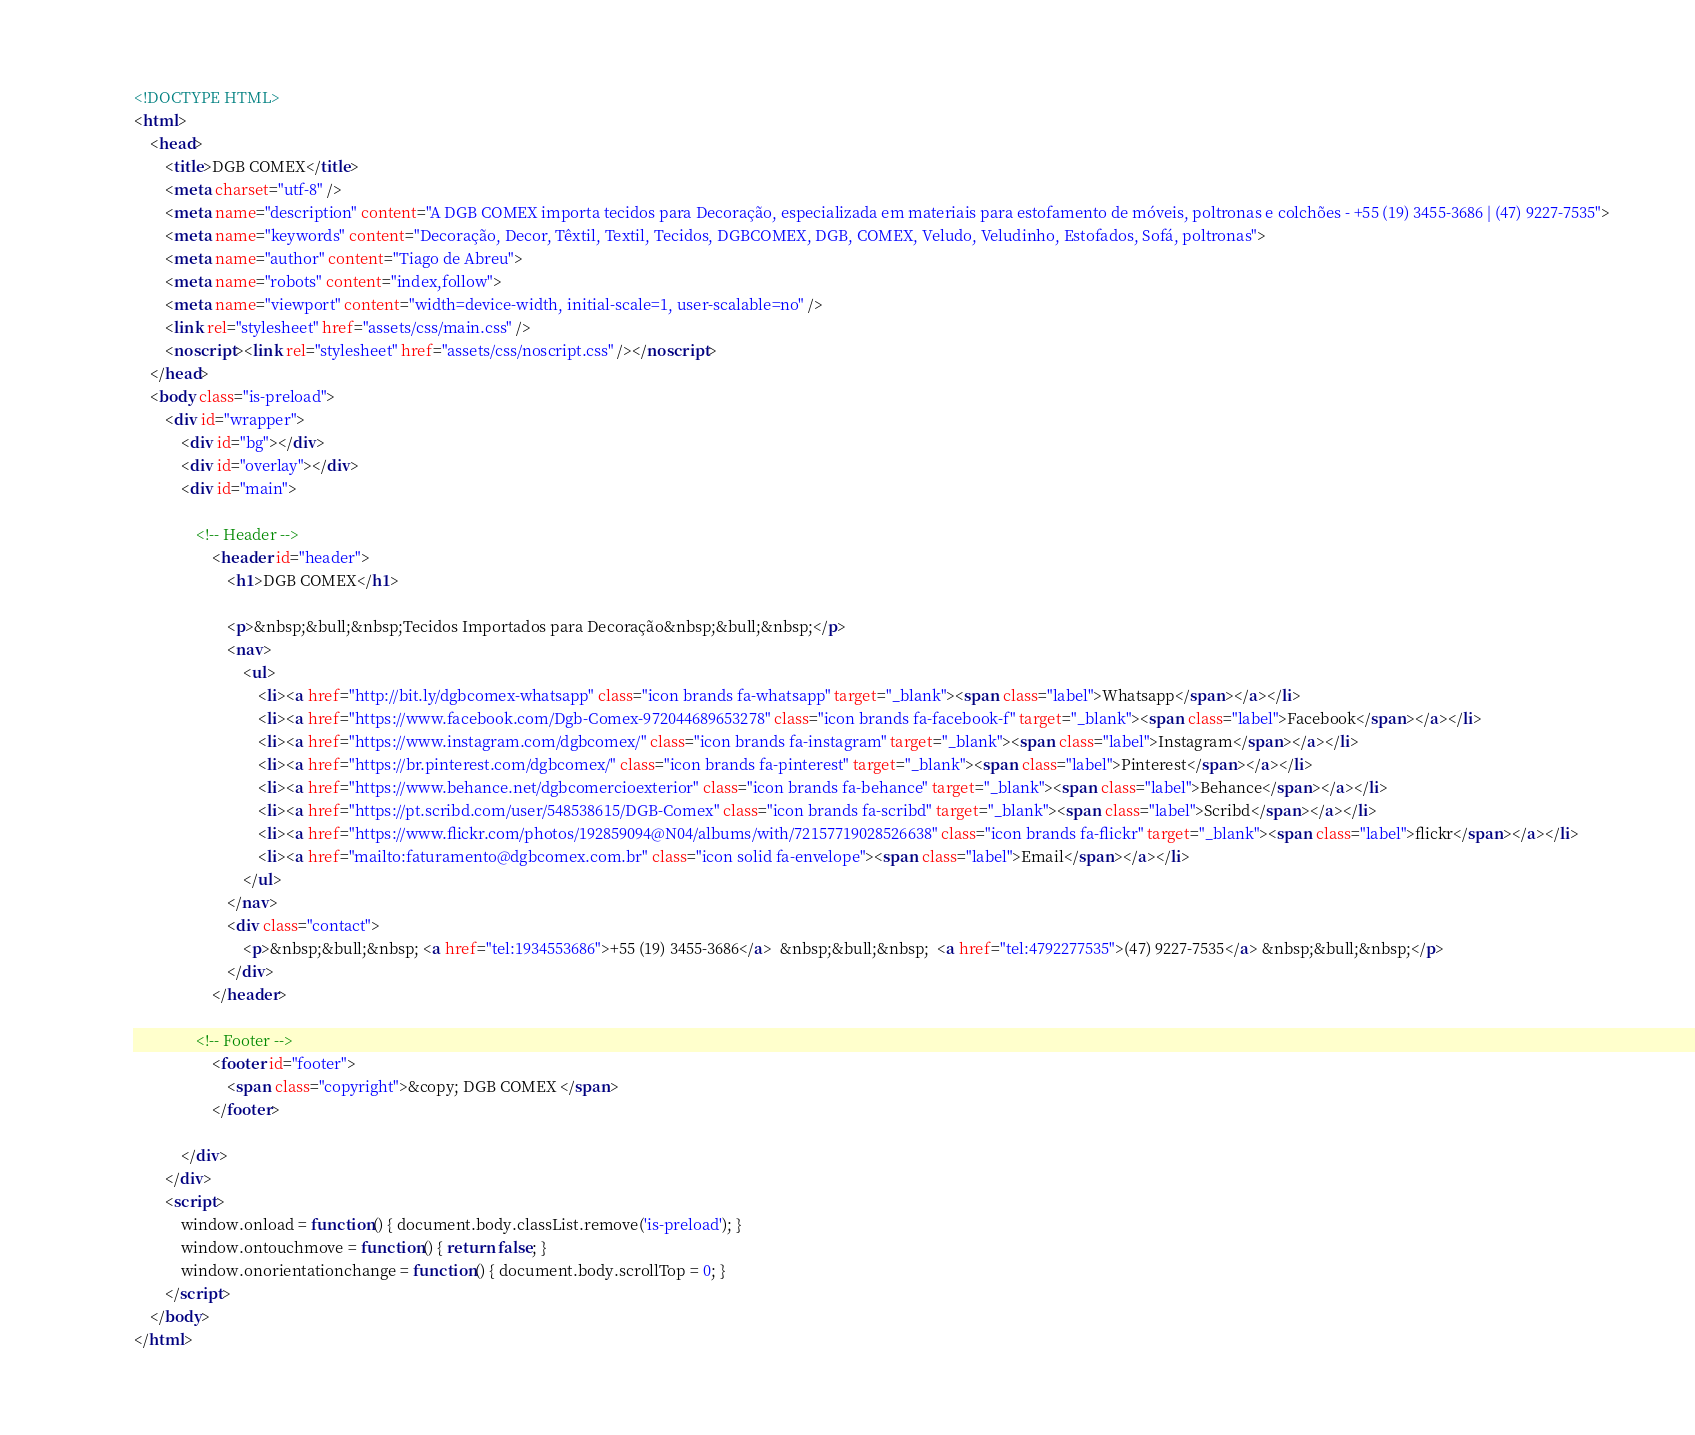<code> <loc_0><loc_0><loc_500><loc_500><_HTML_><!DOCTYPE HTML>
<html>
	<head>
		<title>DGB COMEX</title>
		<meta charset="utf-8" />
		<meta name="description" content="A DGB COMEX importa tecidos para Decoração, especializada em materiais para estofamento de móveis, poltronas e colchões - +55 (19) 3455-3686 | (47) 9227-7535">
		<meta name="keywords" content="Decoração, Decor, Têxtil, Textil, Tecidos, DGBCOMEX, DGB, COMEX, Veludo, Veludinho, Estofados, Sofá, poltronas">
		<meta name="author" content="Tiago de Abreu">
		<meta name="robots" content="index,follow">
		<meta name="viewport" content="width=device-width, initial-scale=1, user-scalable=no" />
		<link rel="stylesheet" href="assets/css/main.css" />
		<noscript><link rel="stylesheet" href="assets/css/noscript.css" /></noscript>
	</head>
	<body class="is-preload">
		<div id="wrapper">
			<div id="bg"></div>
			<div id="overlay"></div>
			<div id="main">

				<!-- Header -->
					<header id="header">
						<h1>DGB COMEX</h1>
				
						<p>&nbsp;&bull;&nbsp;Tecidos Importados para Decoração&nbsp;&bull;&nbsp;</p>
						<nav>
							<ul>
								<li><a href="http://bit.ly/dgbcomex-whatsapp" class="icon brands fa-whatsapp" target="_blank"><span class="label">Whatsapp</span></a></li>
								<li><a href="https://www.facebook.com/Dgb-Comex-972044689653278" class="icon brands fa-facebook-f" target="_blank"><span class="label">Facebook</span></a></li>
								<li><a href="https://www.instagram.com/dgbcomex/" class="icon brands fa-instagram" target="_blank"><span class="label">Instagram</span></a></li>
								<li><a href="https://br.pinterest.com/dgbcomex/" class="icon brands fa-pinterest" target="_blank"><span class="label">Pinterest</span></a></li>
								<li><a href="https://www.behance.net/dgbcomercioexterior" class="icon brands fa-behance" target="_blank"><span class="label">Behance</span></a></li>
								<li><a href="https://pt.scribd.com/user/548538615/DGB-Comex" class="icon brands fa-scribd" target="_blank"><span class="label">Scribd</span></a></li>
								<li><a href="https://www.flickr.com/photos/192859094@N04/albums/with/72157719028526638" class="icon brands fa-flickr" target="_blank"><span class="label">flickr</span></a></li>
								<li><a href="mailto:faturamento@dgbcomex.com.br" class="icon solid fa-envelope"><span class="label">Email</span></a></li>
							</ul>
						</nav>
						<div class="contact">
							<p>&nbsp;&bull;&nbsp; <a href="tel:1934553686">+55 (19) 3455-3686</a>  &nbsp;&bull;&nbsp;  <a href="tel:4792277535">(47) 9227-7535</a> &nbsp;&bull;&nbsp;</p>
						</div>
					</header>

				<!-- Footer -->
					<footer id="footer">
						<span class="copyright">&copy; DGB COMEX </span>
					</footer>

			</div>
		</div>
		<script>
			window.onload = function() { document.body.classList.remove('is-preload'); }
			window.ontouchmove = function() { return false; }
			window.onorientationchange = function() { document.body.scrollTop = 0; }
		</script>
	</body>
</html></code> 